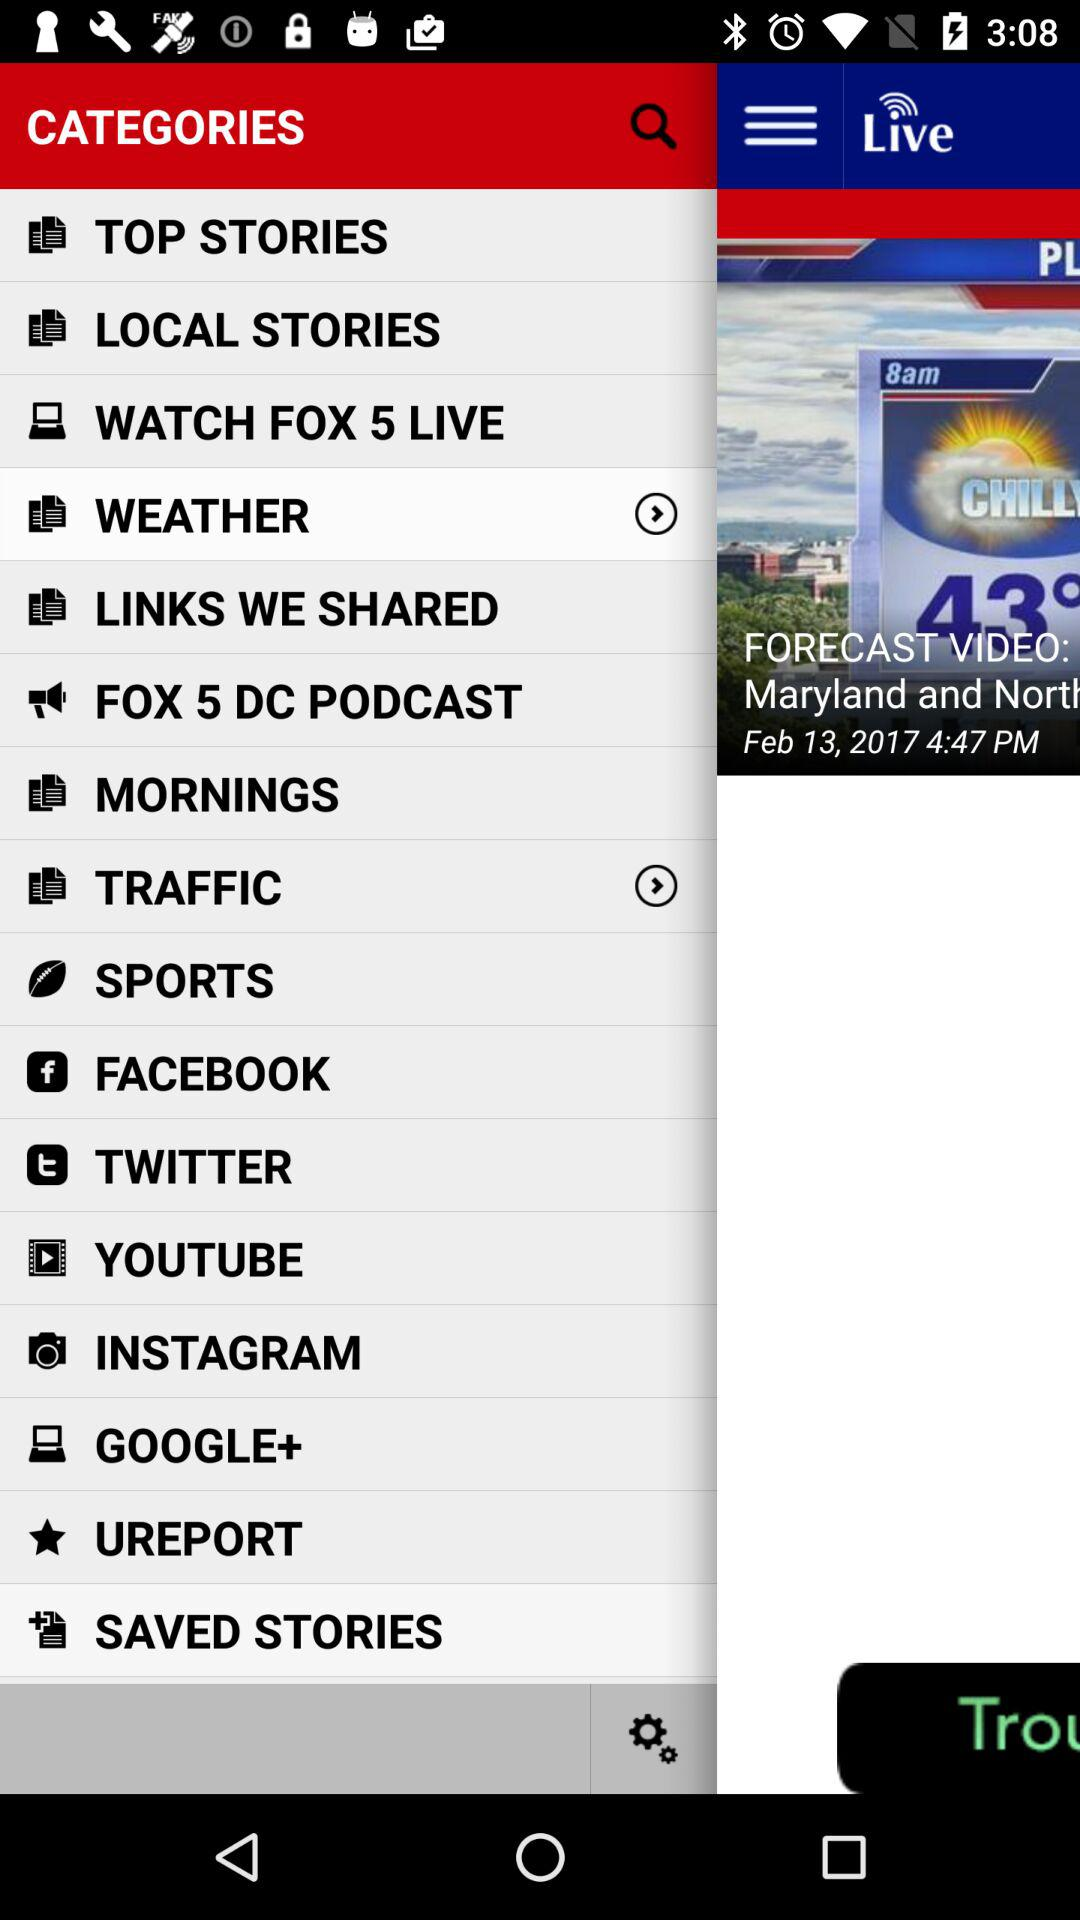What is the date of the forecast video? The date of the forecast video is February 13, 2017. 